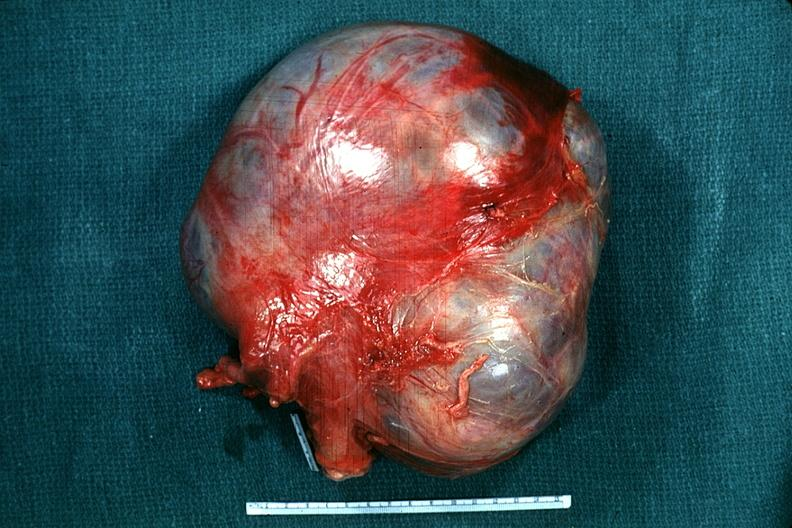s chronic ischemia present?
Answer the question using a single word or phrase. No 